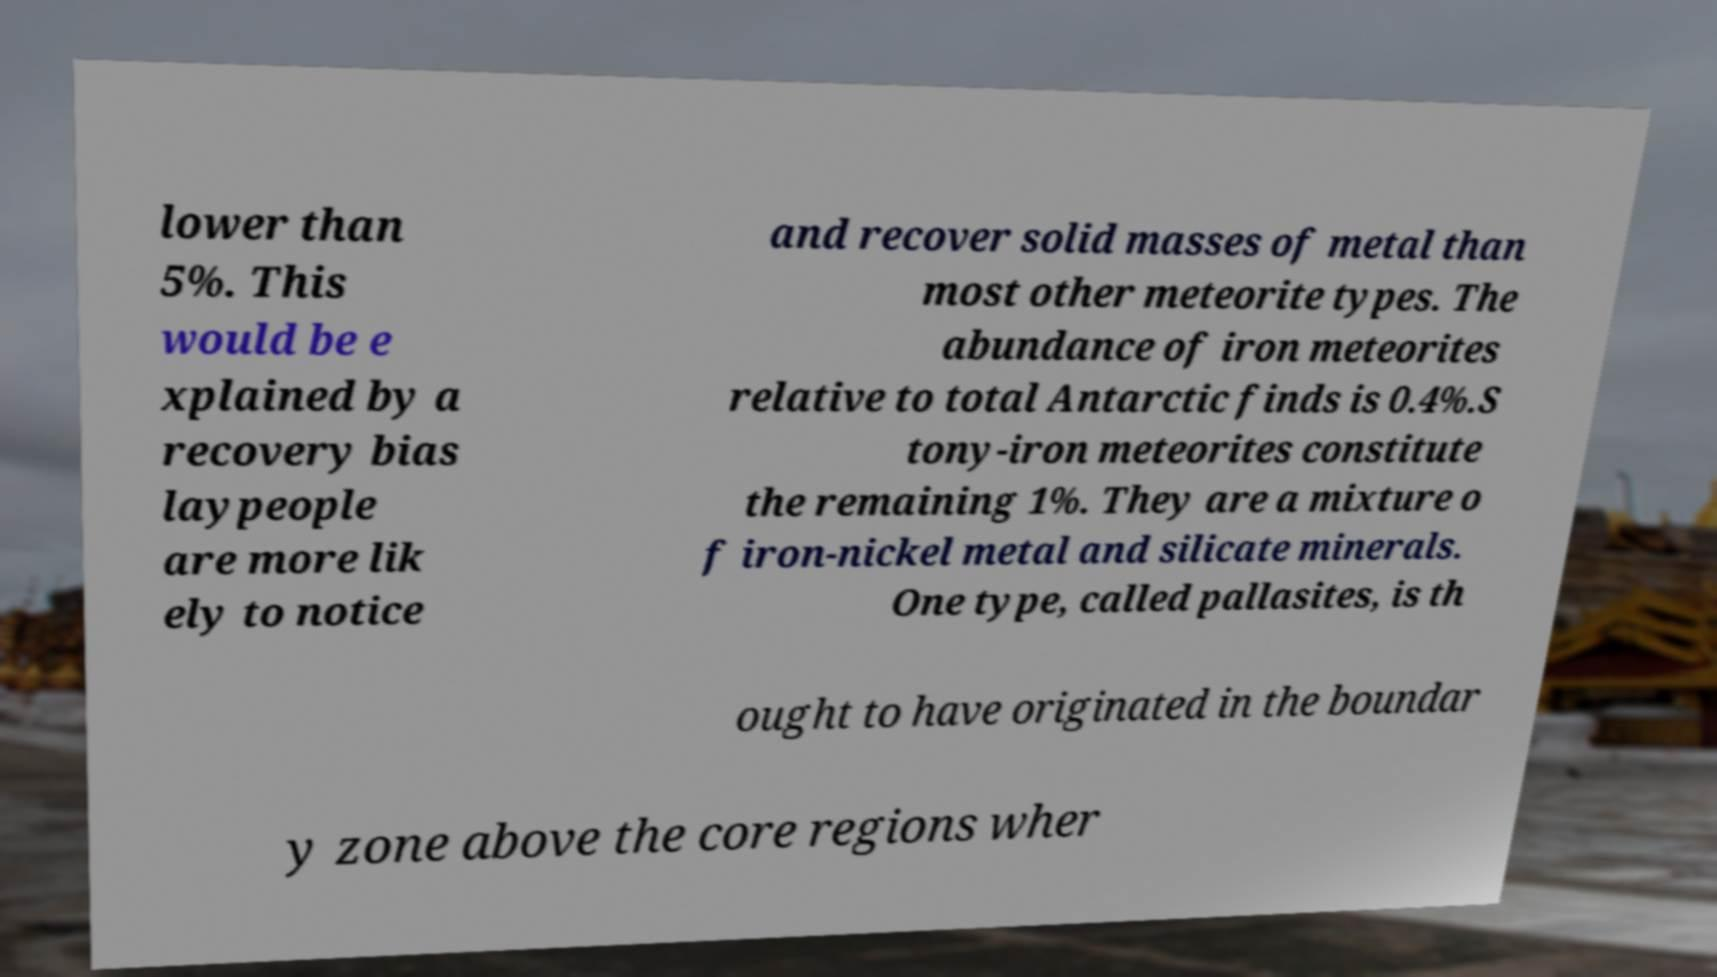I need the written content from this picture converted into text. Can you do that? lower than 5%. This would be e xplained by a recovery bias laypeople are more lik ely to notice and recover solid masses of metal than most other meteorite types. The abundance of iron meteorites relative to total Antarctic finds is 0.4%.S tony-iron meteorites constitute the remaining 1%. They are a mixture o f iron-nickel metal and silicate minerals. One type, called pallasites, is th ought to have originated in the boundar y zone above the core regions wher 